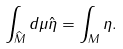<formula> <loc_0><loc_0><loc_500><loc_500>\int _ { \widehat { M } } d \mu \hat { \eta } = \int _ { M } \eta .</formula> 